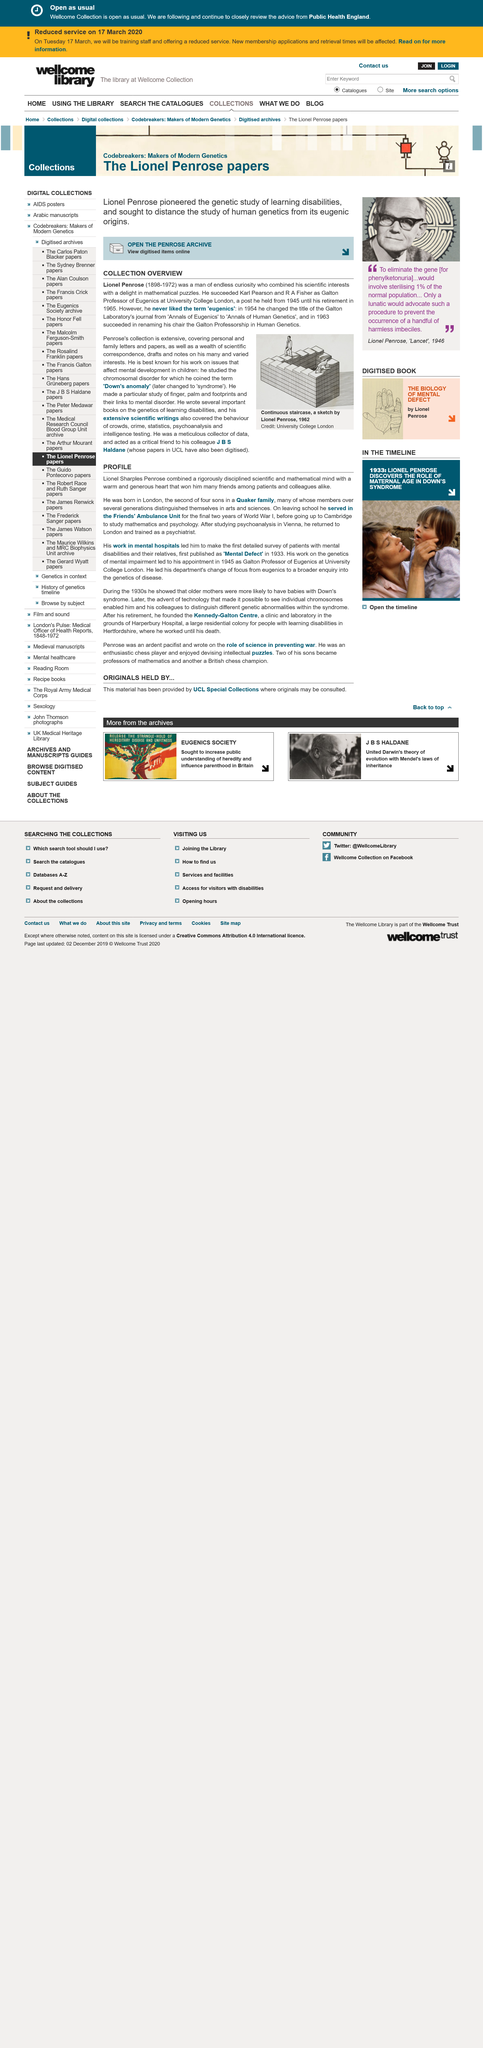Point out several critical features in this image. The image was sketched by Lionel Penrose. Lionel Penrose was born in 1898. He was born in 1898. Lionel Sharples Penrose was born in London, according to his "PROFILE. Lionel studied psychoanalysis in Vienna. Lionel had three brothers, as stated in the sentence. 